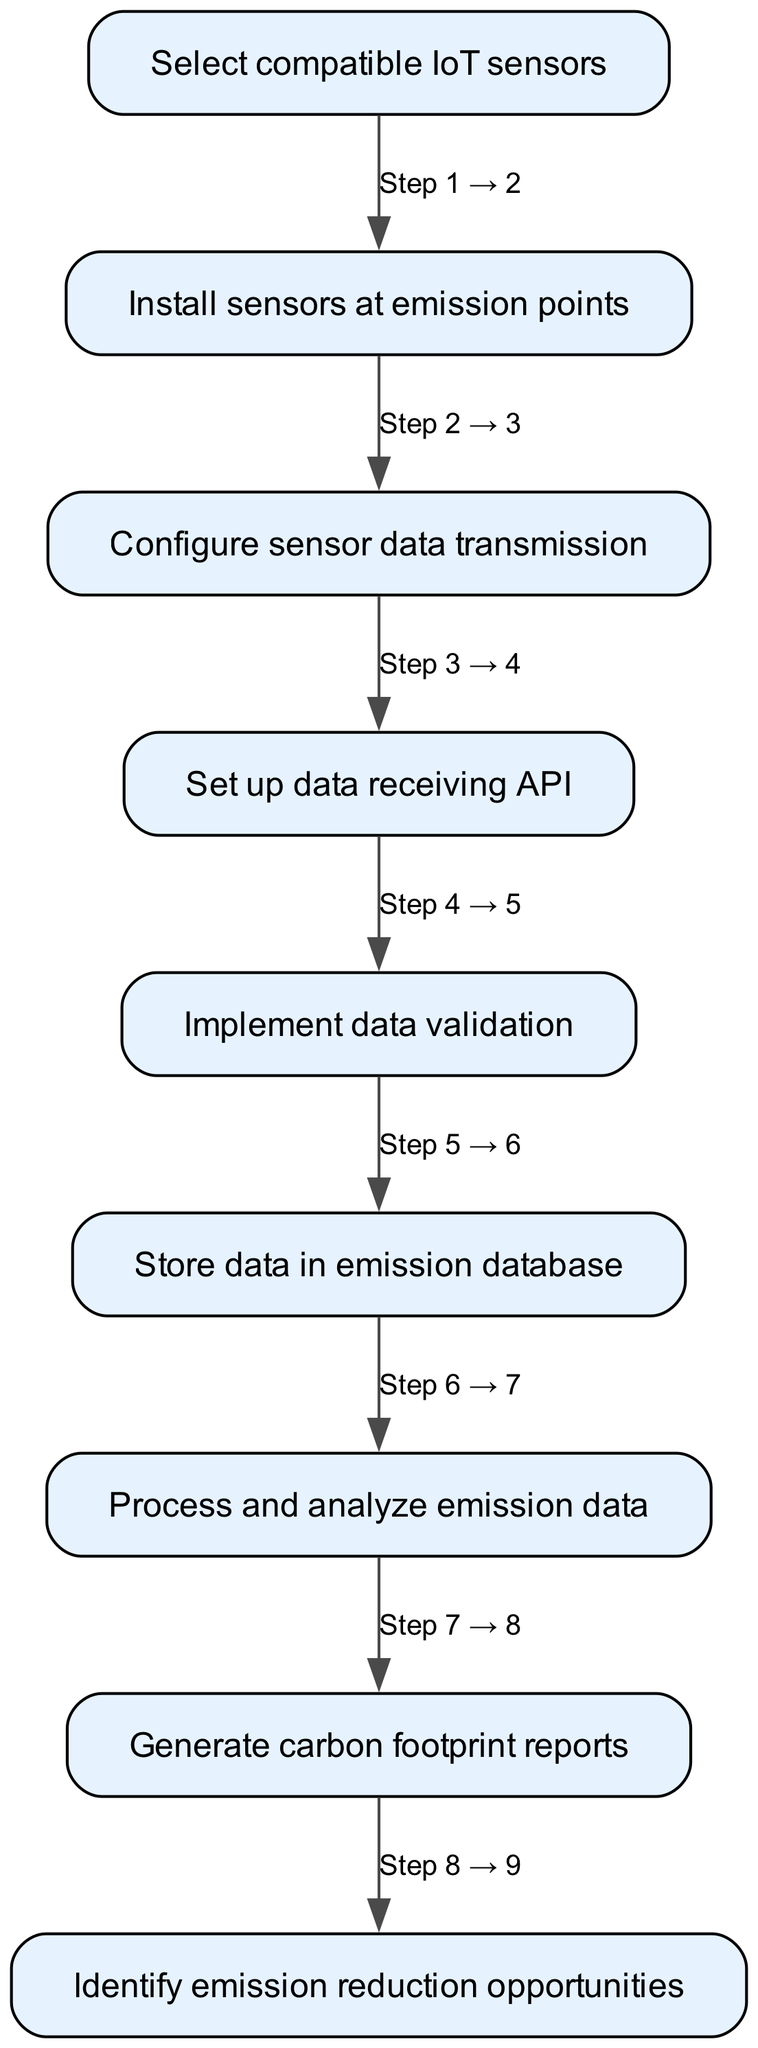What is the first step in the workflow? The first step in the workflow is labeled as "1" and corresponds to selecting compatible IoT sensors. It is the initial instruction that starts the integration process.
Answer: Select compatible IoT sensors How many nodes are present in the diagram? The diagram lists elements numbered from 1 to 9, indicating a total of 9 distinct steps in the workflow.
Answer: 9 What step comes after "Implement data validation"? Following "Implement data validation", which is step 5, the next step in the workflow is "Store data in emission database", labeled as step 6.
Answer: Store data in emission database What is the last step of the workflow? The last step of the workflow is labeled as "9" and is "Identify emission reduction opportunities", marking the final action in the integration process.
Answer: Identify emission reduction opportunities How many steps are there between "Configure sensor data transmission" and "Process and analyze emission data"? The workflow lists "Configure sensor data transmission" as step 3 and "Process and analyze emission data" as step 7. Counting the intermediate steps (4, 5, 6), there are 3 steps between these two points.
Answer: 3 steps What does the edge from "Set up data receiving API" to "Implement data validation" show? The edge illustrates the directional flow of the process, indicating that after setting up the data receiving API (step 4), the next action to take is "Implement data validation" (step 5).
Answer: Directional flow What is the connection between the step for "Process and analyze emission data" and generating reports? "Process and analyze emission data" is step 7, and it directly leads to "Generate carbon footprint reports", which is step 8, indicating a sequential relationship where analysis is performed before report generation.
Answer: Sequential relationship Which steps require physical installation of equipment? The steps that involve physical installation include "Select compatible IoT sensors" (step 1) and "Install sensors at emission points" (step 2), as they pertain to the setup of IoT equipment for monitoring.
Answer: 1 and 2 What action is taken after "Generate carbon footprint reports"? The action taken after "Generate carbon footprint reports", which is step 8, is to "Identify emission reduction opportunities", indicating a focus on utilizing the reports for future improvements.
Answer: Identify emission reduction opportunities 